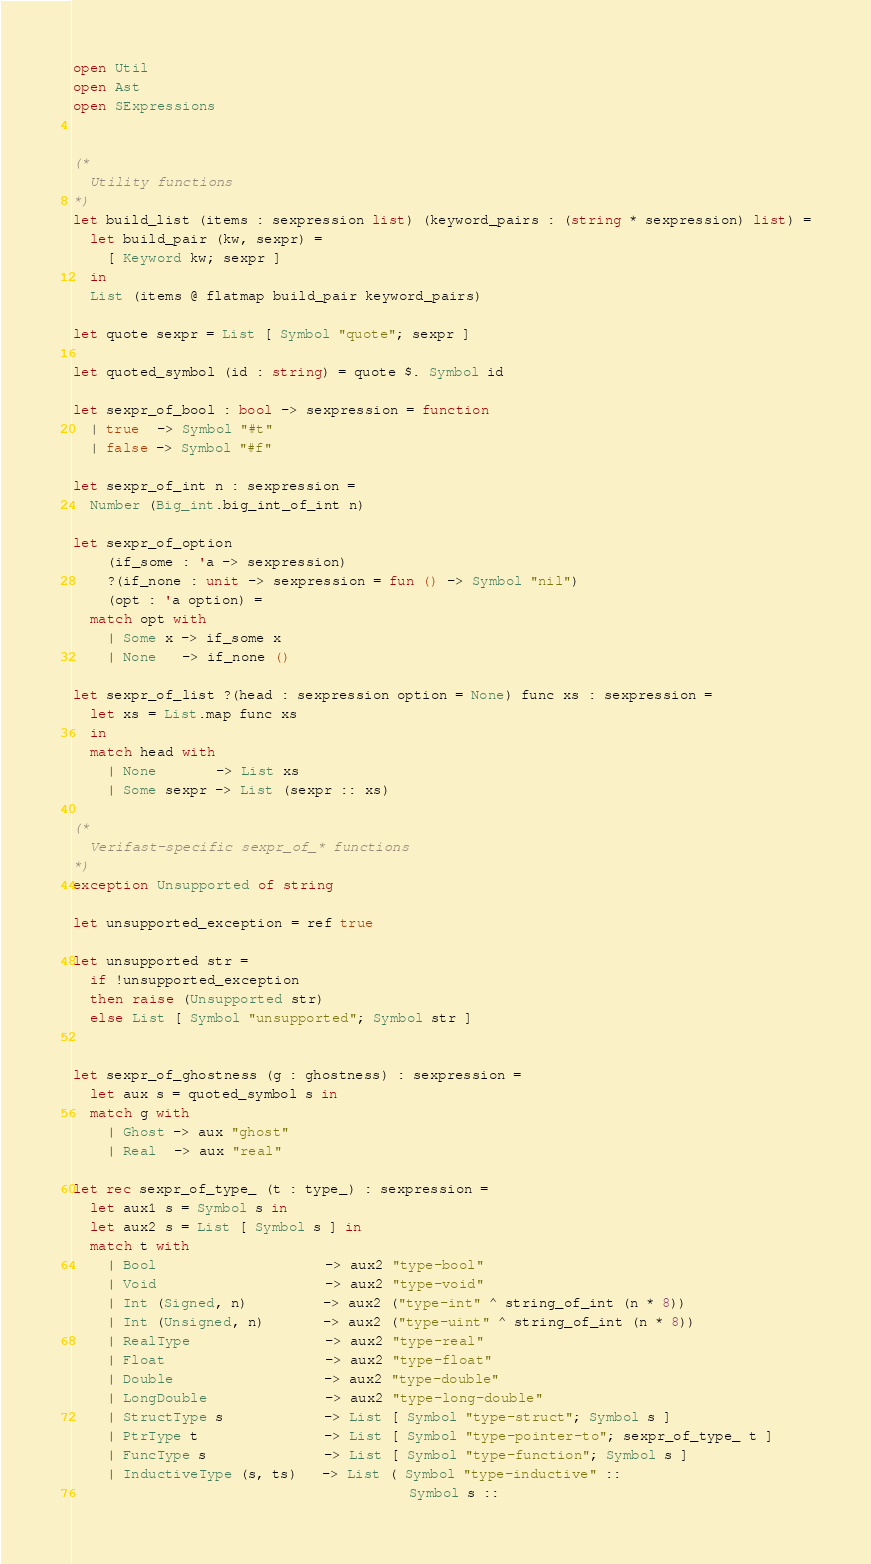Convert code to text. <code><loc_0><loc_0><loc_500><loc_500><_OCaml_>open Util
open Ast
open SExpressions


(*
  Utility functions
*)
let build_list (items : sexpression list) (keyword_pairs : (string * sexpression) list) =
  let build_pair (kw, sexpr) =
    [ Keyword kw; sexpr ]
  in
  List (items @ flatmap build_pair keyword_pairs)

let quote sexpr = List [ Symbol "quote"; sexpr ]

let quoted_symbol (id : string) = quote $. Symbol id

let sexpr_of_bool : bool -> sexpression = function
  | true  -> Symbol "#t"
  | false -> Symbol "#f"

let sexpr_of_int n : sexpression =
  Number (Big_int.big_int_of_int n)

let sexpr_of_option
    (if_some : 'a -> sexpression)
    ?(if_none : unit -> sexpression = fun () -> Symbol "nil")
    (opt : 'a option) =
  match opt with
    | Some x -> if_some x
    | None   -> if_none ()

let sexpr_of_list ?(head : sexpression option = None) func xs : sexpression =
  let xs = List.map func xs
  in
  match head with
    | None       -> List xs
    | Some sexpr -> List (sexpr :: xs)

(*
  Verifast-specific sexpr_of_* functions
*)
exception Unsupported of string

let unsupported_exception = ref true

let unsupported str =
  if !unsupported_exception
  then raise (Unsupported str)
  else List [ Symbol "unsupported"; Symbol str ]


let sexpr_of_ghostness (g : ghostness) : sexpression =
  let aux s = quoted_symbol s in
  match g with
    | Ghost -> aux "ghost"
    | Real  -> aux "real"

let rec sexpr_of_type_ (t : type_) : sexpression =
  let aux1 s = Symbol s in
  let aux2 s = List [ Symbol s ] in
  match t with
    | Bool                    -> aux2 "type-bool"
    | Void                    -> aux2 "type-void"
    | Int (Signed, n)         -> aux2 ("type-int" ^ string_of_int (n * 8))
    | Int (Unsigned, n)       -> aux2 ("type-uint" ^ string_of_int (n * 8))
    | RealType                -> aux2 "type-real"
    | Float                   -> aux2 "type-float"
    | Double                  -> aux2 "type-double"
    | LongDouble              -> aux2 "type-long-double"
    | StructType s            -> List [ Symbol "type-struct"; Symbol s ]
    | PtrType t               -> List [ Symbol "type-pointer-to"; sexpr_of_type_ t ]
    | FuncType s              -> List [ Symbol "type-function"; Symbol s ]
    | InductiveType (s, ts)   -> List ( Symbol "type-inductive" ::
                                        Symbol s ::</code> 